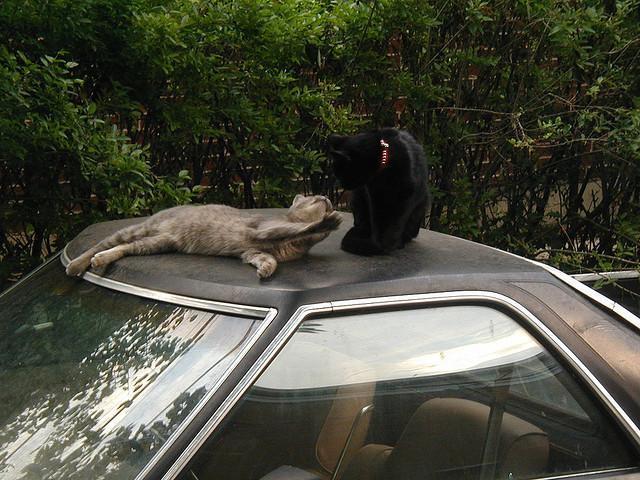How many cats?
Give a very brief answer. 2. How many cats are there?
Give a very brief answer. 2. 